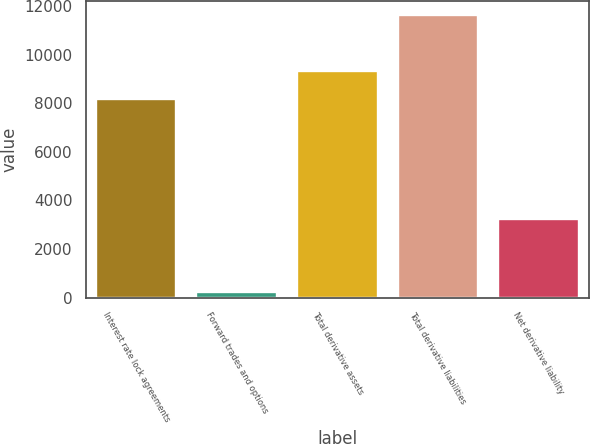<chart> <loc_0><loc_0><loc_500><loc_500><bar_chart><fcel>Interest rate lock agreements<fcel>Forward trades and options<fcel>Total derivative assets<fcel>Total derivative liabilities<fcel>Net derivative liability<nl><fcel>8182<fcel>233<fcel>9322.5<fcel>11638<fcel>3223<nl></chart> 